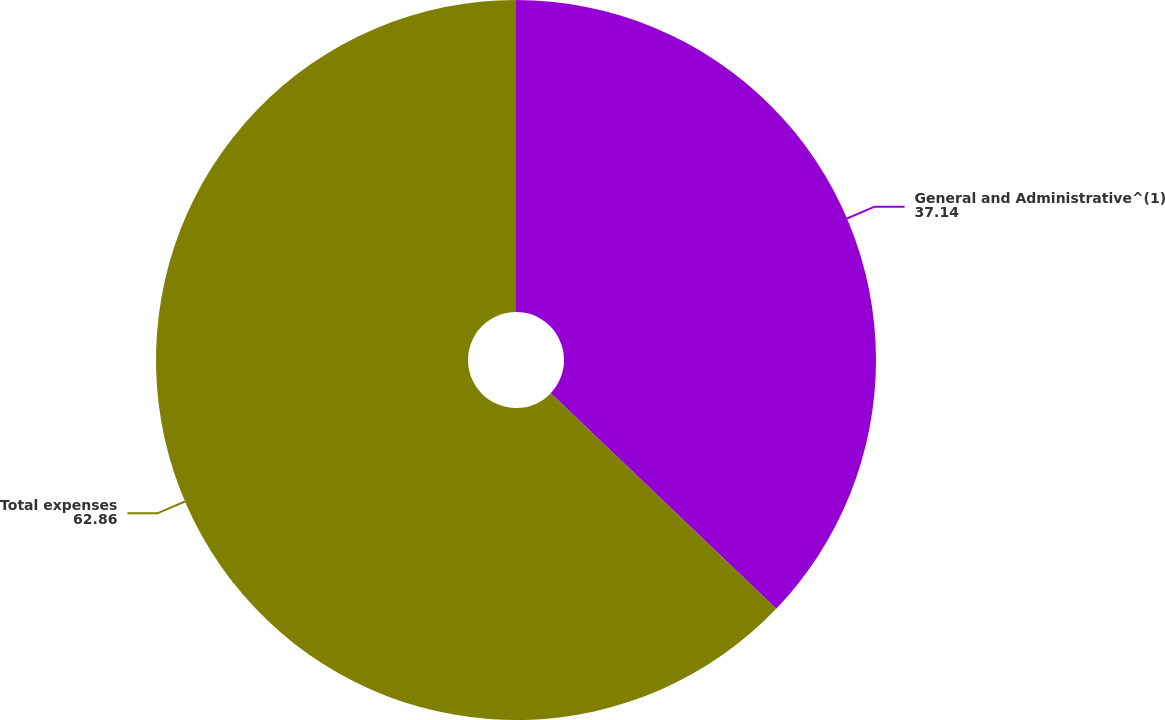Convert chart. <chart><loc_0><loc_0><loc_500><loc_500><pie_chart><fcel>General and Administrative^(1)<fcel>Total expenses<nl><fcel>37.14%<fcel>62.86%<nl></chart> 